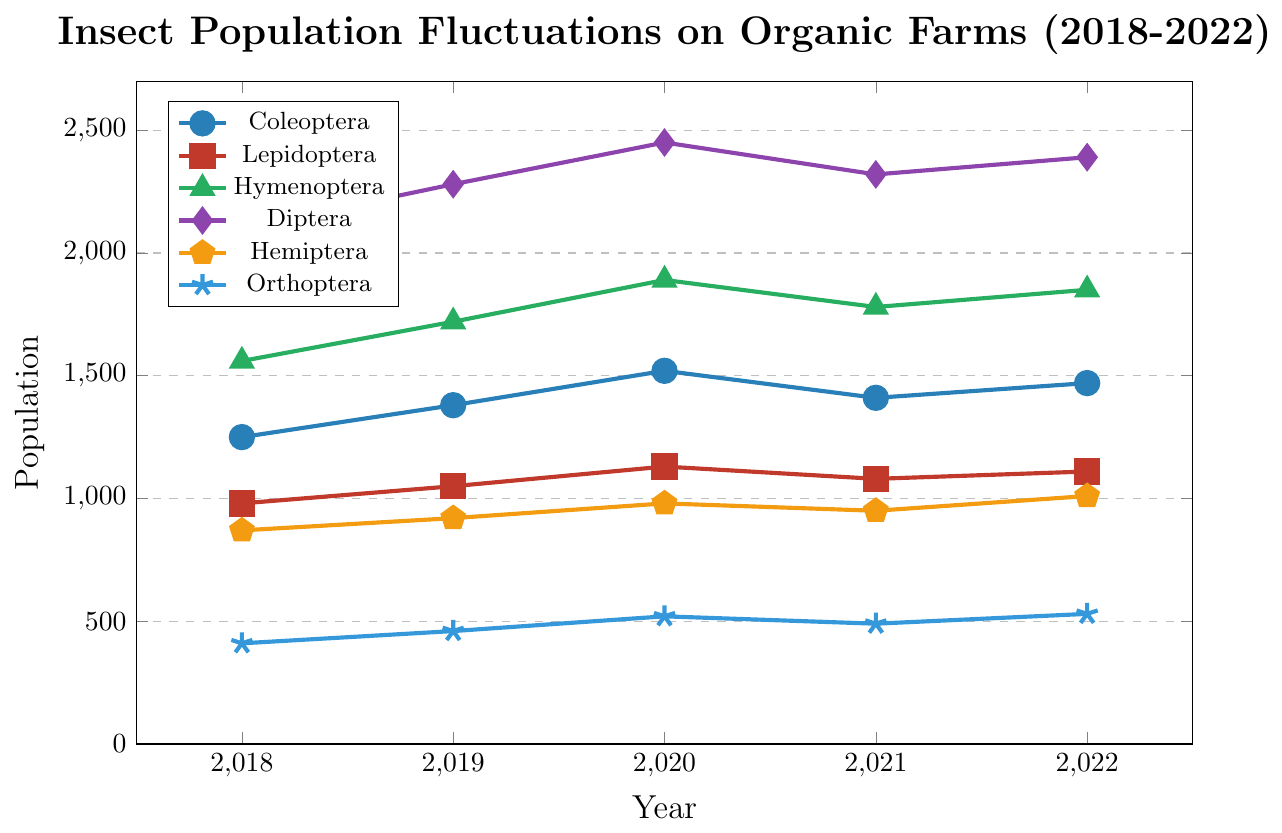What is the overall trend in the population of Diptera from 2018 to 2022? To find the trend, observe the data points for Diptera over the given years: 2100 (2018), 2280 (2019), 2450 (2020), 2320 (2021), and 2390 (2022). The general pattern shows an initial increase from 2100 in 2018 to 2450 in 2020, with a slight decline to 2320 in 2021, followed by an increase to 2390 in 2022. Hence, the trend is an overall increase in population with minor fluctuations.
Answer: Overall increase Which insect order had the highest population in 2020? Look at the data points for each insect order in the year 2020: Coleoptera (1520), Lepidoptera (1130), Hymenoptera (1890), Diptera (2450), Hemiptera (980), and Orthoptera (520). Clearly, Diptera had the highest population in 2020 with 2450.
Answer: Diptera Compare the population trend of Coleoptera and Lepidoptera from 2018 to 2022. Which order showed a more consistent increase? Examine the population values for Coleoptera: 1250 (2018), 1380 (2019), 1520 (2020), 1410 (2021), 1470 (2022). For Lepidoptera: 980 (2018), 1050 (2019), 1130 (2020), 1080 (2021), 1110 (2022). Coleoptera shows an increase until 2020, a slight drop in 2021, and a rise again in 2022. Lepidoptera shows a consistent increase from 2018 to 2020, a drop in 2021, and a slight rise in 2022. Therefore, both orders have fluctuations, but Lepidoptera shows a slightly more consistent increasing trend.
Answer: Lepidoptera What is the average population of Hymenoptera over the 5-year period? Calculate the average by summing the populations for Hymenoptera from 2018 to 2022 and dividing by the number of years. Sum: 1560 (2018) + 1720 (2019) + 1890 (2020) + 1780 (2021) + 1850 (2022) = 8800. Average: 8800 / 5 = 1760.
Answer: 1760 What's the difference between the maximum and minimum populations of Hemiptera across the 5 years? Determine the maximum and minimum populations of Hemiptera: Max is 1010 (2022), Min is 870 (2018). Difference: 1010 - 870 = 140.
Answer: 140 Which year showed the peak population for Orthoptera, and what was the population? Examine the population values for Orthoptera over the years: 410 (2018), 460 (2019), 520 (2020), 490 (2021), 530 (2022). The peak population is in 2022 with 530.
Answer: 2022, 530 Do any insect orders exhibit a population decrease in any given year from one year to the next? If so, which ones and between which years? Analyze the year-on-year data for each order: 
- Coleoptera: Increased till 2020, decreased in 2021, increased in 2022.
- Lepidoptera: Increased till 2020, decreased in 2021, increased in 2022.
- Hymenoptera: Increased till 2020, decreased in 2021, increased in 2022.
- Diptera: Increased till 2020, decreased in 2021, increased in 2022.
- Hemiptera: Steady increase.
- Orthoptera: Increased till 2020, decreased in 2021, increased in 2022.
Therefore, Coleoptera, Lepidoptera, Hymenoptera, Diptera, and Orthoptera showed a population decrease from 2020 to 2021.
Answer: Coleoptera, Lepidoptera, Hymenoptera, Diptera, Orthoptera; 2020-2021 What is the sum of the populations of Hemiptera in the years 2019 and 2022? Add the populations of Hemiptera for 2019 (920) and 2022 (1010). Sum: 920 + 1010 = 1930.
Answer: 1930 